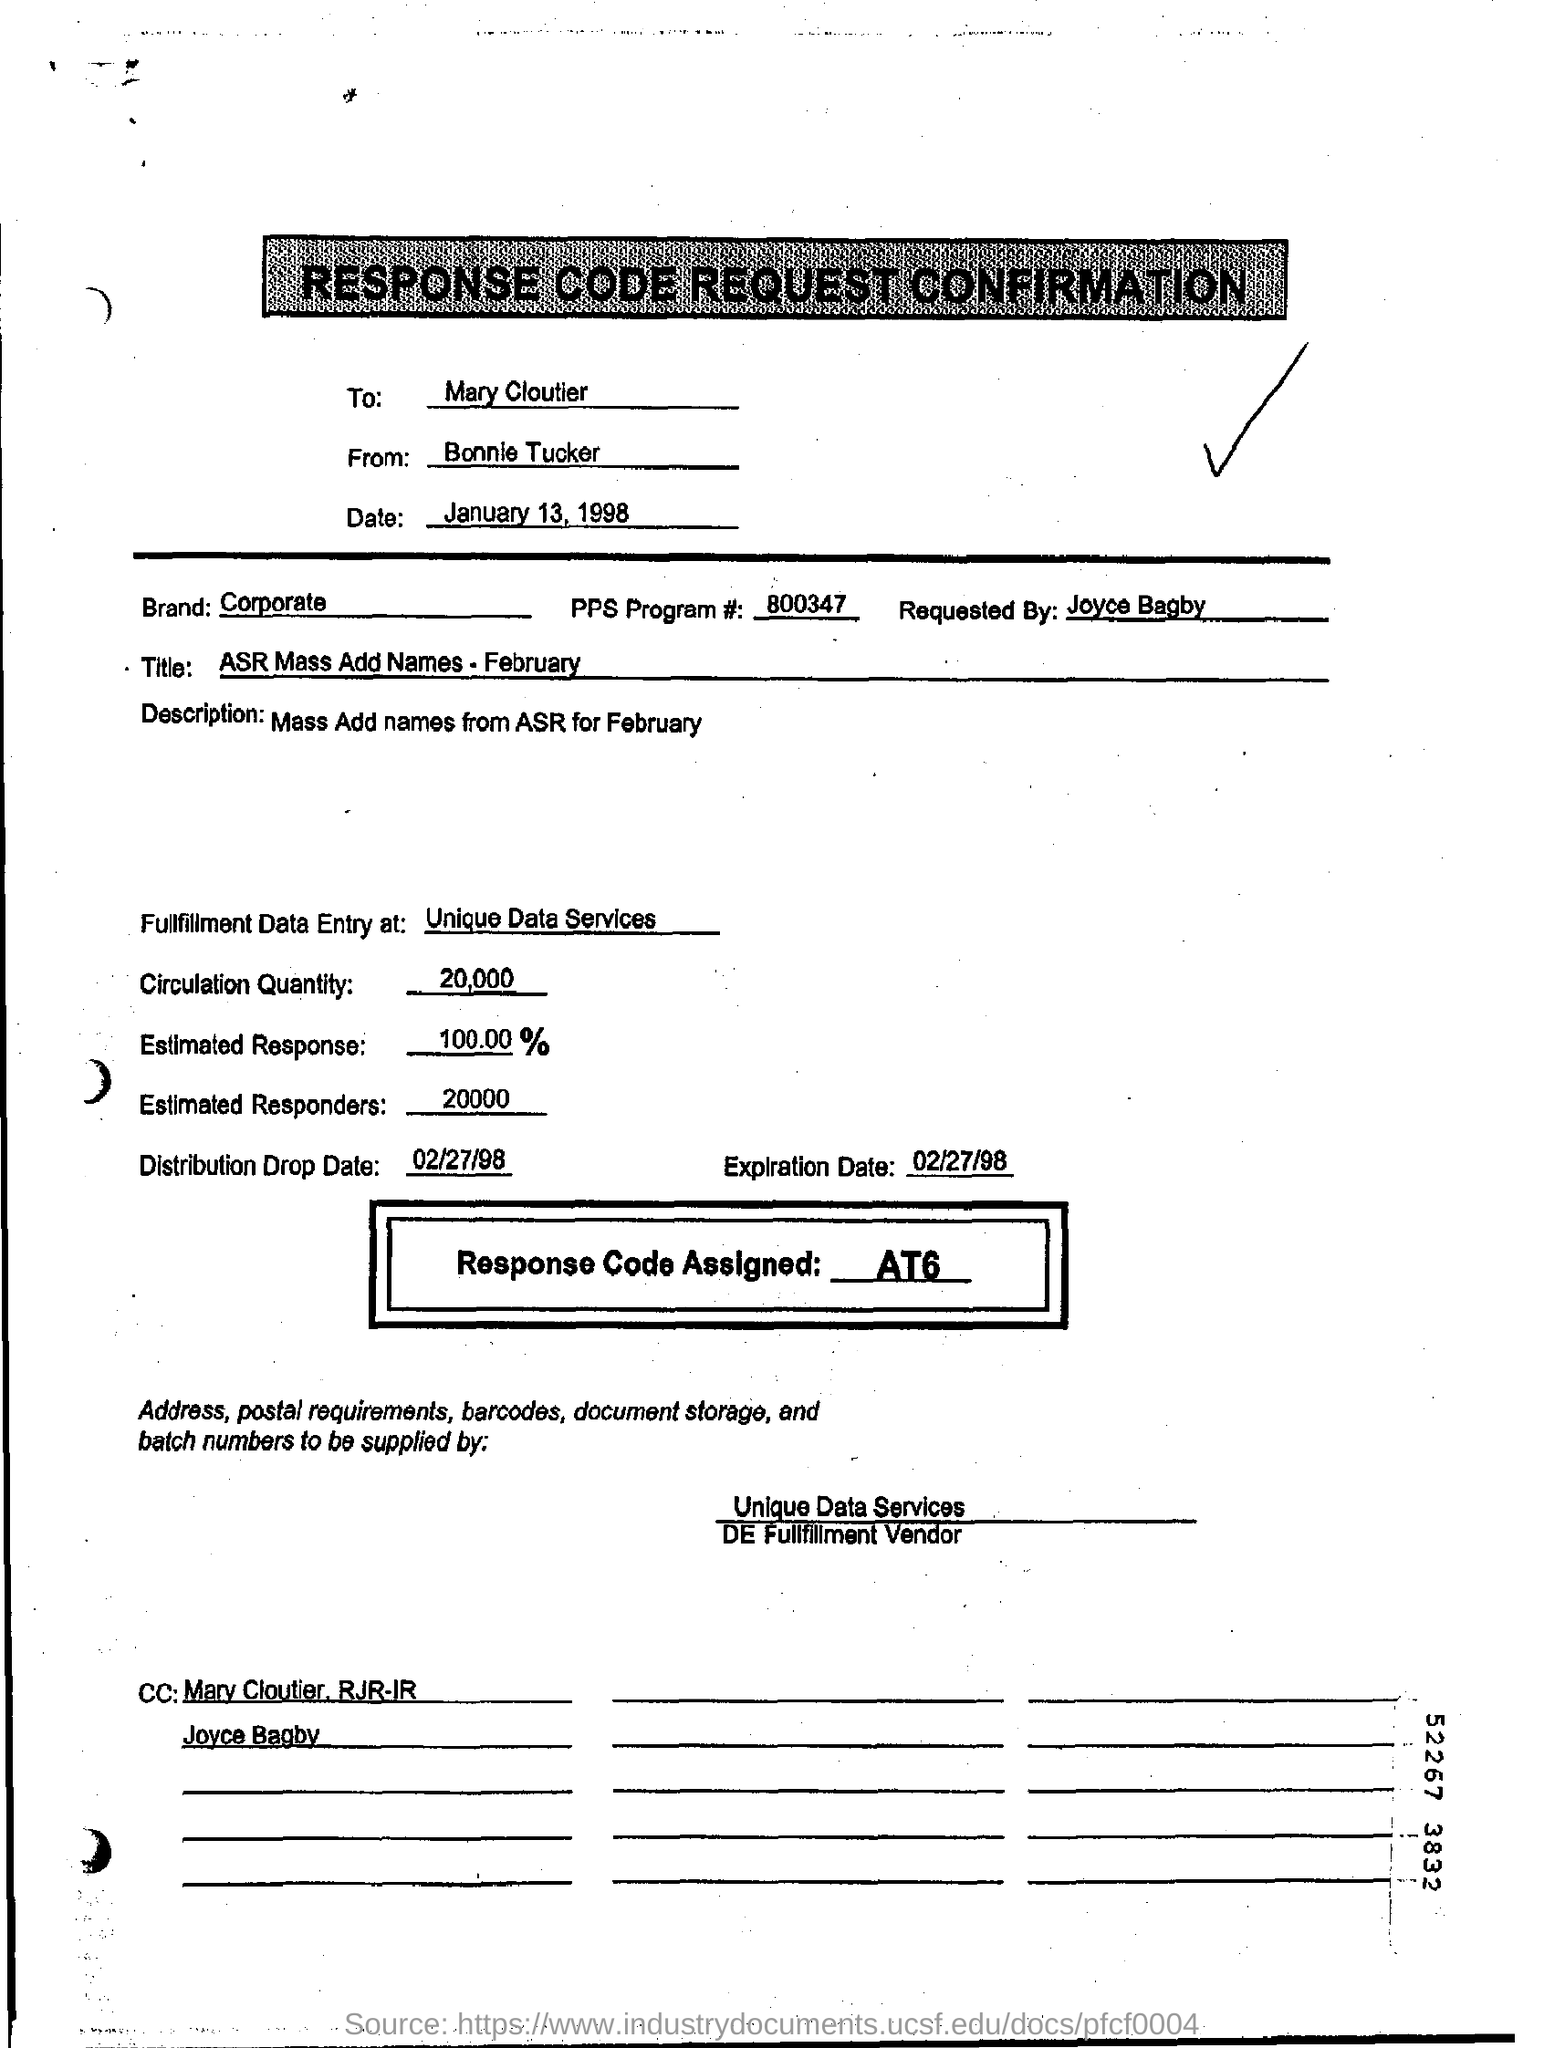What is the response code assigned ?
Provide a short and direct response. At6. What is the estimated response ?
Give a very brief answer. 100.00. What is the distribution drop date ?
Your answer should be very brief. 02/27/98. What is the Circulation Quantity ?
Offer a very short reply. 20,000. What is the FPS program #?
Offer a terse response. 800347. Who made the request?
Ensure brevity in your answer.  Joyce Bagby. 